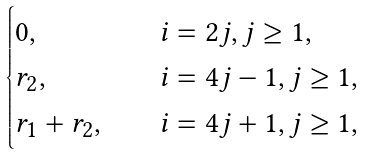<formula> <loc_0><loc_0><loc_500><loc_500>\begin{cases} 0 , & \quad i = 2 j , j \geq 1 , \\ r _ { 2 } , & \quad i = 4 j - 1 , j \geq 1 , \\ r _ { 1 } + r _ { 2 } , & \quad i = 4 j + 1 , j \geq 1 , \end{cases}</formula> 